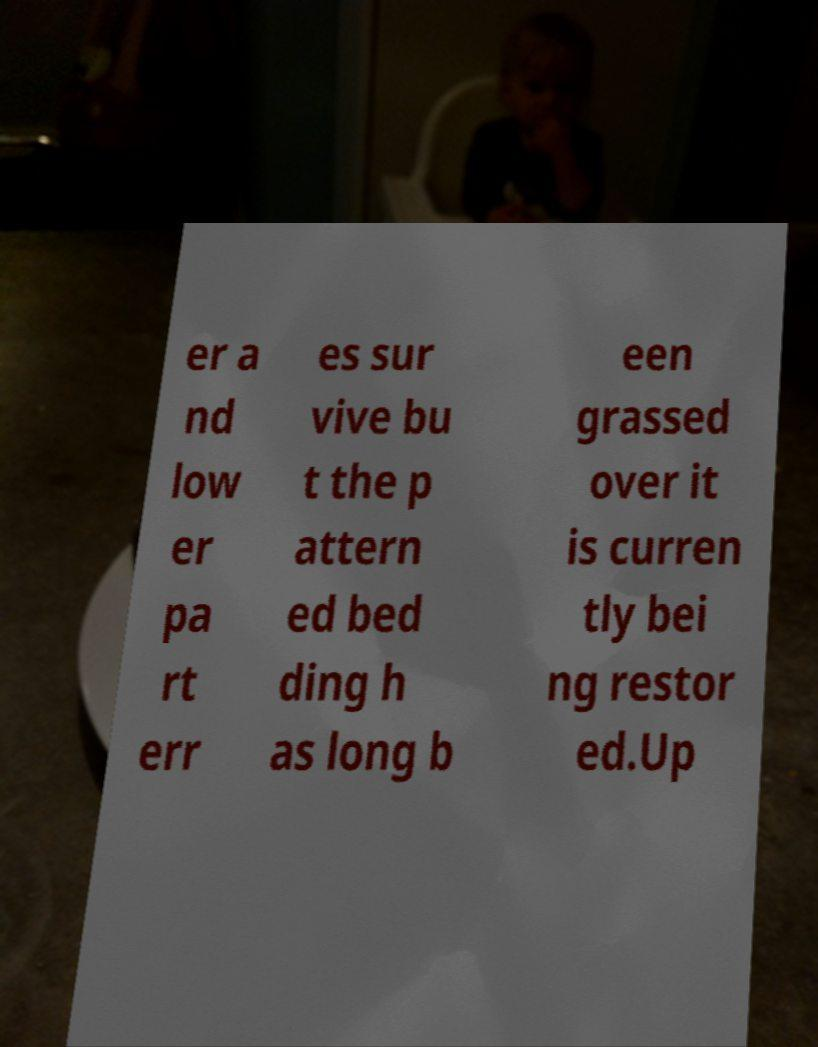For documentation purposes, I need the text within this image transcribed. Could you provide that? er a nd low er pa rt err es sur vive bu t the p attern ed bed ding h as long b een grassed over it is curren tly bei ng restor ed.Up 